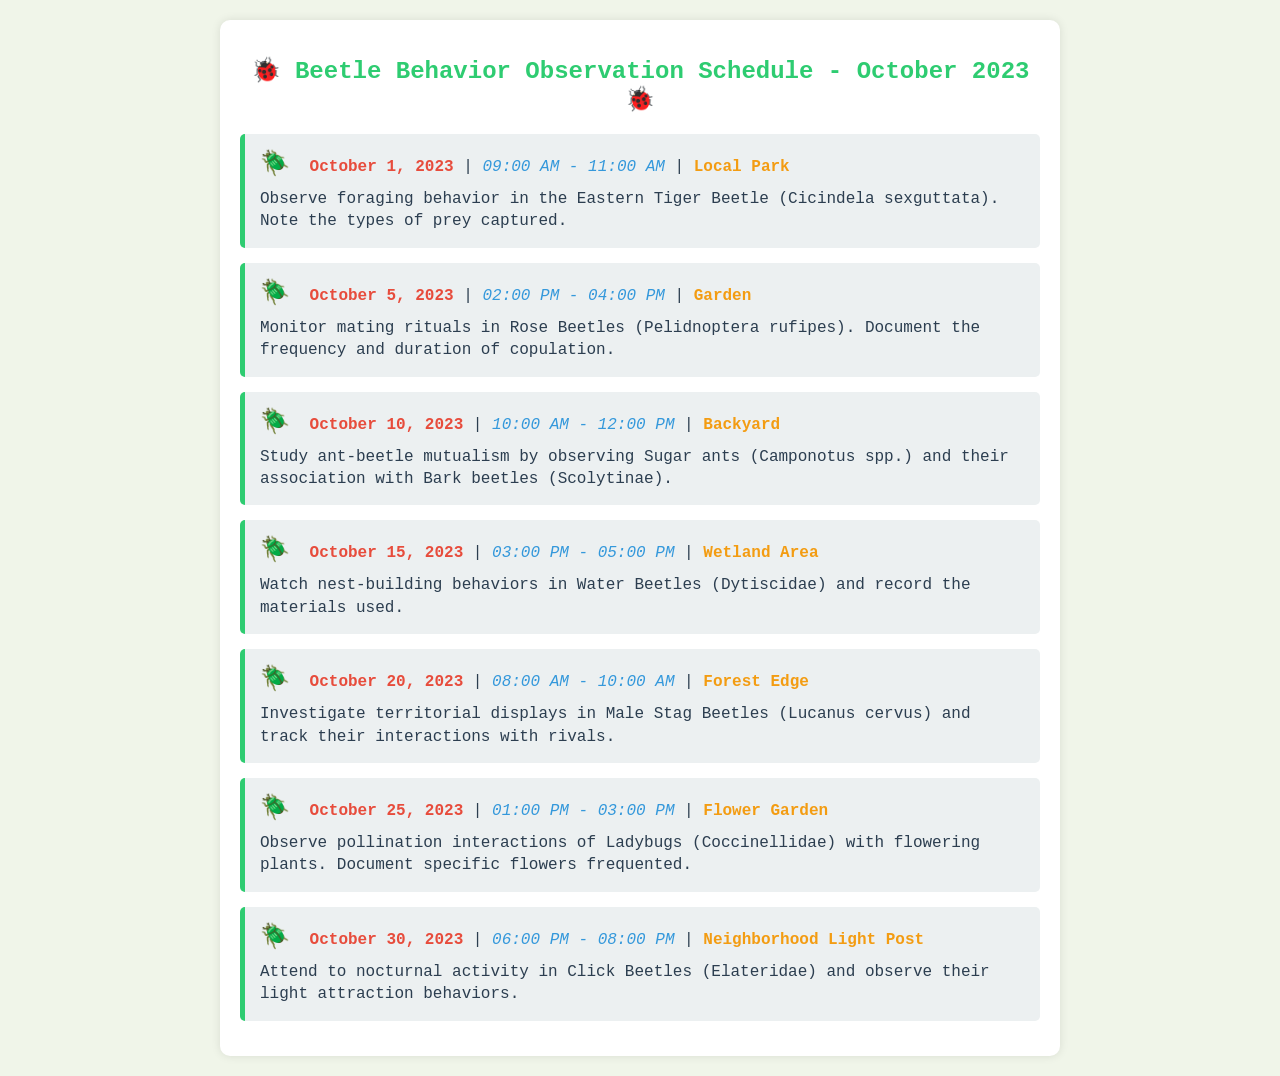What is the first observation date? The first observation date listed in the schedule is the earliest date, which is October 1, 2023.
Answer: October 1, 2023 How many hours are designated for observing Click Beetles on October 30, 2023? The time slot for observing Click Beetles is from 06:00 PM to 08:00 PM, which is a total of 2 hours.
Answer: 2 hours What is the location for observing Eastern Tiger Beetles? The location listed for observing Eastern Tiger Beetles is specified in the schedule as Local Park.
Answer: Local Park What behavior is observed on October 20, 2023? The behavior to be observed on this date is territorial displays in Male Stag Beetles.
Answer: Territorial displays What insects are monitored for mating rituals on October 5, 2023? The schedule indicates Rose Beetles are the insects being monitored for mating rituals on this date.
Answer: Rose Beetles How many observation sessions are planned for the month? The schedule lists a total of 7 observation sessions throughout October 2023.
Answer: 7 sessions Which beetles are associated with ant-beetle mutualism? The document states that Bark beetles are the beetles associated with ant-beetle mutualism on October 10, 2023.
Answer: Bark beetles What time does the observation on October 25, 2023, start? The observation on this date starts at 01:00 PM as per the schedule.
Answer: 01:00 PM What materials should be recorded during nest-building observations on October 15, 2023? The schedule instructs to record the materials used during the nest-building behaviors of Water Beetles.
Answer: Materials used 